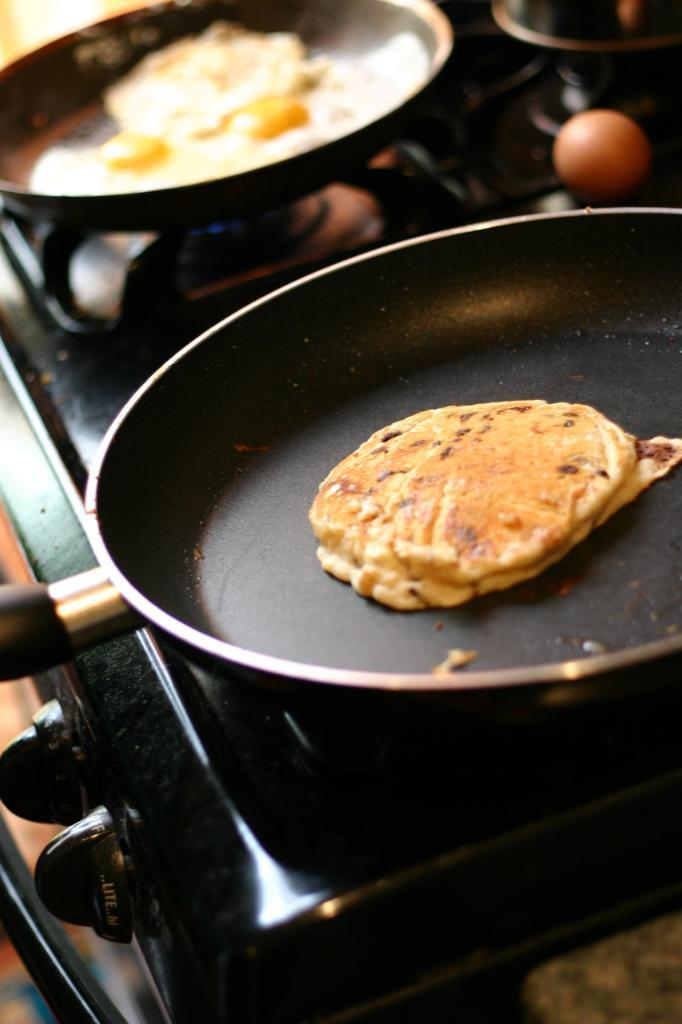What is the main object in the center of the image? There is a stove in the center of the image. What is being cooked on the stove? There are two pans with food on the stove. Can you describe anything else visible in the image? There is an egg visible in the top right of the image. What religious symbols can be seen in the image? There are no religious symbols present in the image. Are there any dolls visible in the image? There are no dolls present in the image. 